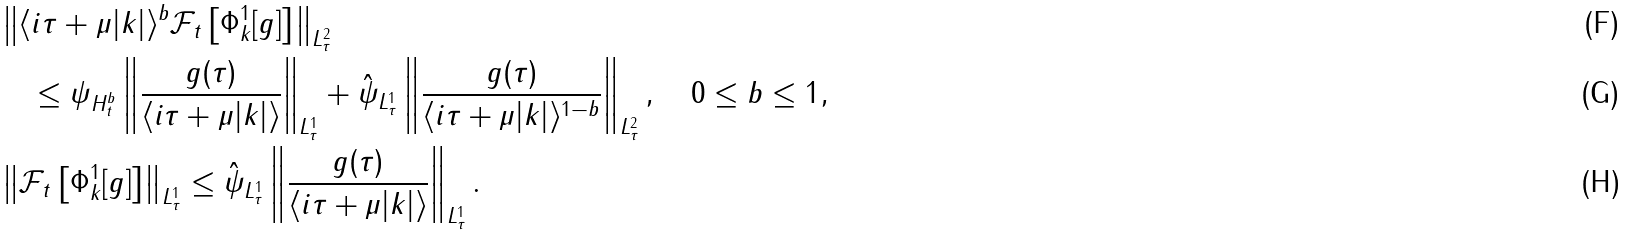<formula> <loc_0><loc_0><loc_500><loc_500>& \left \| \langle i \tau + \mu | k | \rangle ^ { b } \mathcal { F } _ { t } \left [ \Phi ^ { 1 } _ { k } [ g ] \right ] \right \| _ { L ^ { 2 } _ { \tau } } \\ & \quad \leq \| \psi \| _ { H ^ { b } _ { t } } \left \| \frac { g ( \tau ) } { \langle i \tau + \mu | k | \rangle } \right \| _ { L ^ { 1 } _ { \tau } } + \| \hat { \psi } \| _ { L ^ { 1 } _ { \tau } } \left \| \frac { g ( \tau ) } { \langle i \tau + \mu | k | \rangle ^ { 1 - b } } \right \| _ { L ^ { 2 } _ { \tau } } , \quad 0 \leq b \leq 1 , \\ & \left \| \mathcal { F } _ { t } \left [ \Phi ^ { 1 } _ { k } [ g ] \right ] \right \| _ { L ^ { 1 } _ { \tau } } \leq \| \hat { \psi } \| _ { L ^ { 1 } _ { \tau } } \left \| \frac { g ( \tau ) } { \langle i \tau + \mu | k | \rangle } \right \| _ { L ^ { 1 } _ { \tau } } .</formula> 